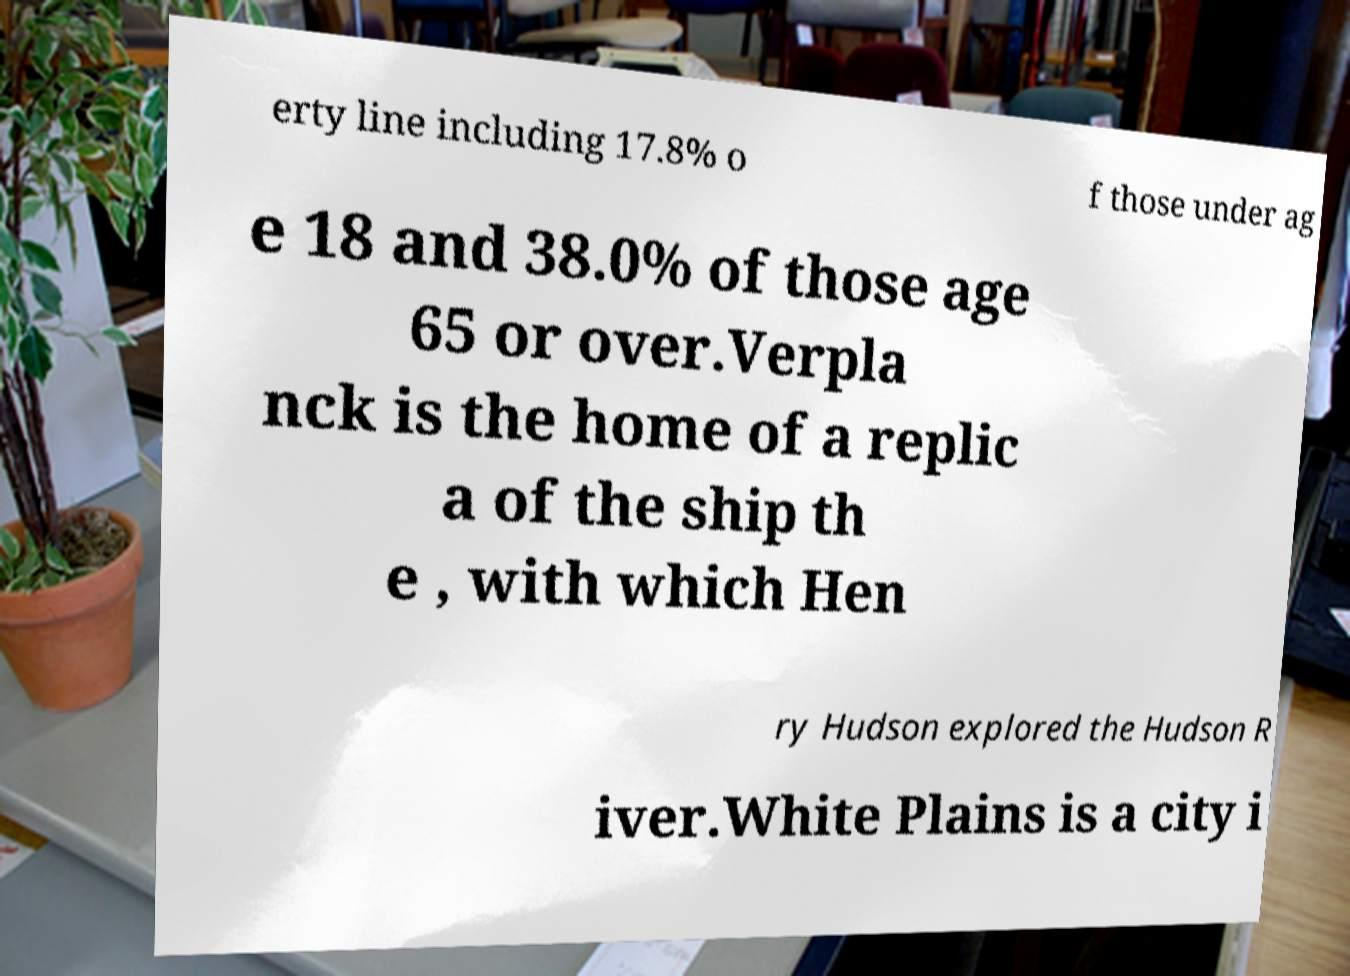Please identify and transcribe the text found in this image. erty line including 17.8% o f those under ag e 18 and 38.0% of those age 65 or over.Verpla nck is the home of a replic a of the ship th e , with which Hen ry Hudson explored the Hudson R iver.White Plains is a city i 